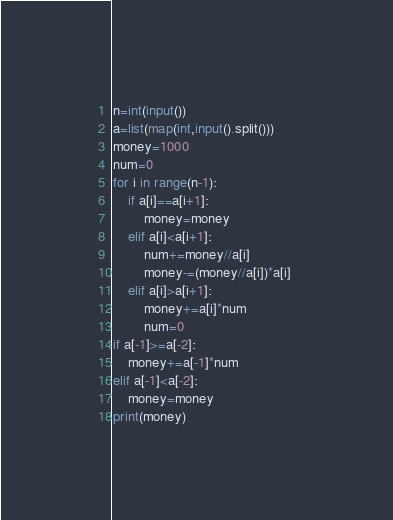<code> <loc_0><loc_0><loc_500><loc_500><_Python_>n=int(input())
a=list(map(int,input().split()))
money=1000
num=0
for i in range(n-1):
    if a[i]==a[i+1]:
        money=money
    elif a[i]<a[i+1]:
        num+=money//a[i]
        money-=(money//a[i])*a[i] 
    elif a[i]>a[i+1]:
        money+=a[i]*num
        num=0 
if a[-1]>=a[-2]:
    money+=a[-1]*num
elif a[-1]<a[-2]:
    money=money
print(money)
</code> 